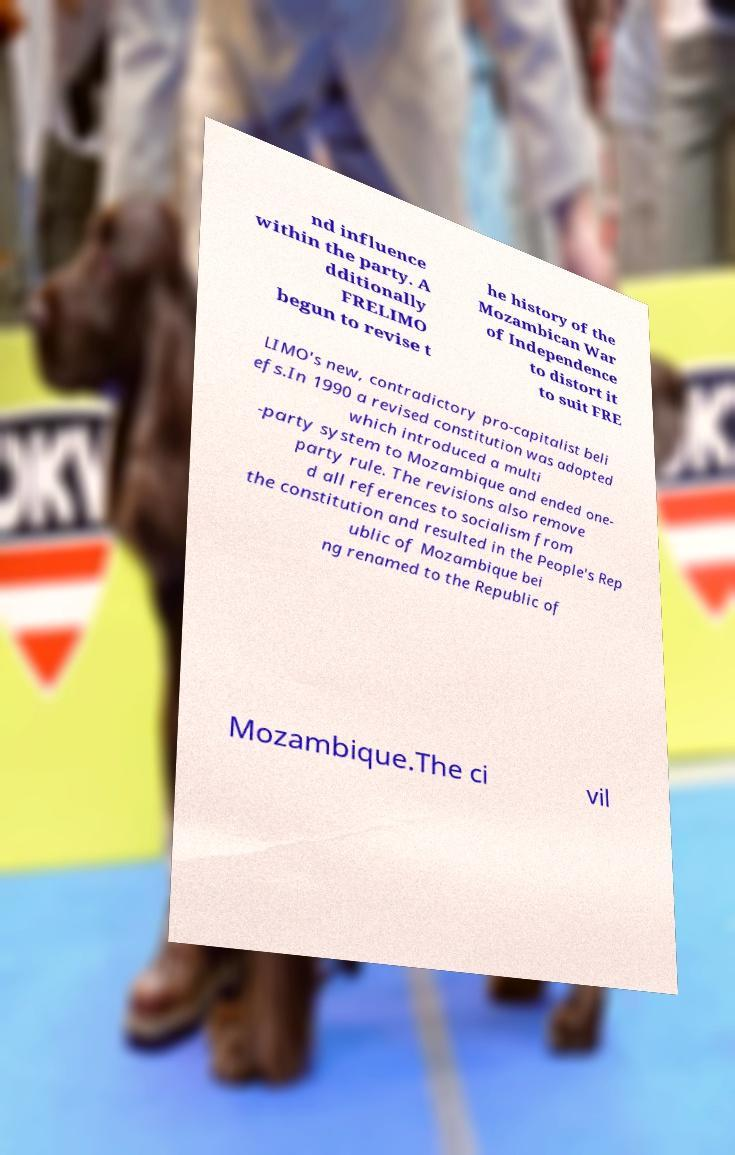I need the written content from this picture converted into text. Can you do that? nd influence within the party. A dditionally FRELIMO begun to revise t he history of the Mozambican War of Independence to distort it to suit FRE LIMO's new, contradictory pro-capitalist beli efs.In 1990 a revised constitution was adopted which introduced a multi -party system to Mozambique and ended one- party rule. The revisions also remove d all references to socialism from the constitution and resulted in the People's Rep ublic of Mozambique bei ng renamed to the Republic of Mozambique.The ci vil 